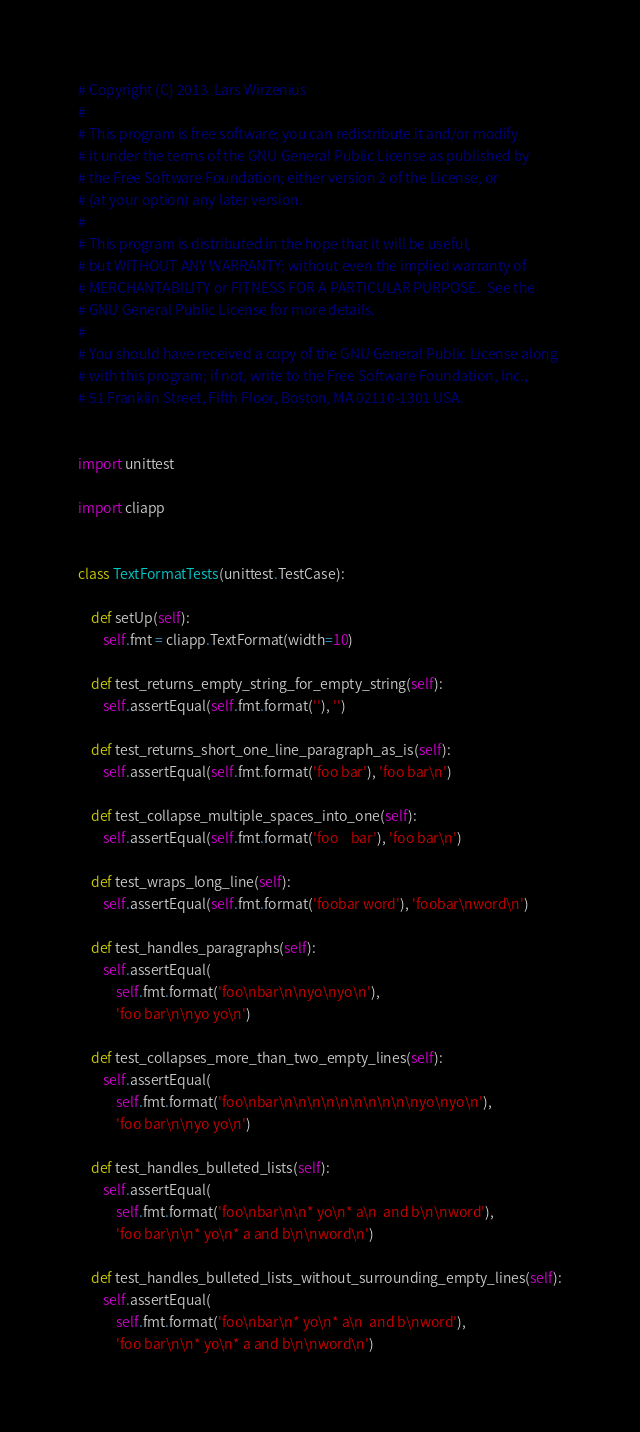<code> <loc_0><loc_0><loc_500><loc_500><_Python_># Copyright (C) 2013  Lars Wirzenius
#
# This program is free software; you can redistribute it and/or modify
# it under the terms of the GNU General Public License as published by
# the Free Software Foundation; either version 2 of the License, or
# (at your option) any later version.
#
# This program is distributed in the hope that it will be useful,
# but WITHOUT ANY WARRANTY; without even the implied warranty of
# MERCHANTABILITY or FITNESS FOR A PARTICULAR PURPOSE.  See the
# GNU General Public License for more details.
#
# You should have received a copy of the GNU General Public License along
# with this program; if not, write to the Free Software Foundation, Inc.,
# 51 Franklin Street, Fifth Floor, Boston, MA 02110-1301 USA.


import unittest

import cliapp


class TextFormatTests(unittest.TestCase):

    def setUp(self):
        self.fmt = cliapp.TextFormat(width=10)

    def test_returns_empty_string_for_empty_string(self):
        self.assertEqual(self.fmt.format(''), '')

    def test_returns_short_one_line_paragraph_as_is(self):
        self.assertEqual(self.fmt.format('foo bar'), 'foo bar\n')

    def test_collapse_multiple_spaces_into_one(self):
        self.assertEqual(self.fmt.format('foo    bar'), 'foo bar\n')

    def test_wraps_long_line(self):
        self.assertEqual(self.fmt.format('foobar word'), 'foobar\nword\n')

    def test_handles_paragraphs(self):
        self.assertEqual(
            self.fmt.format('foo\nbar\n\nyo\nyo\n'),
            'foo bar\n\nyo yo\n')

    def test_collapses_more_than_two_empty_lines(self):
        self.assertEqual(
            self.fmt.format('foo\nbar\n\n\n\n\n\n\n\n\n\nyo\nyo\n'),
            'foo bar\n\nyo yo\n')

    def test_handles_bulleted_lists(self):
        self.assertEqual(
            self.fmt.format('foo\nbar\n\n* yo\n* a\n  and b\n\nword'),
            'foo bar\n\n* yo\n* a and b\n\nword\n')

    def test_handles_bulleted_lists_without_surrounding_empty_lines(self):
        self.assertEqual(
            self.fmt.format('foo\nbar\n* yo\n* a\n  and b\nword'),
            'foo bar\n\n* yo\n* a and b\n\nword\n')

</code> 